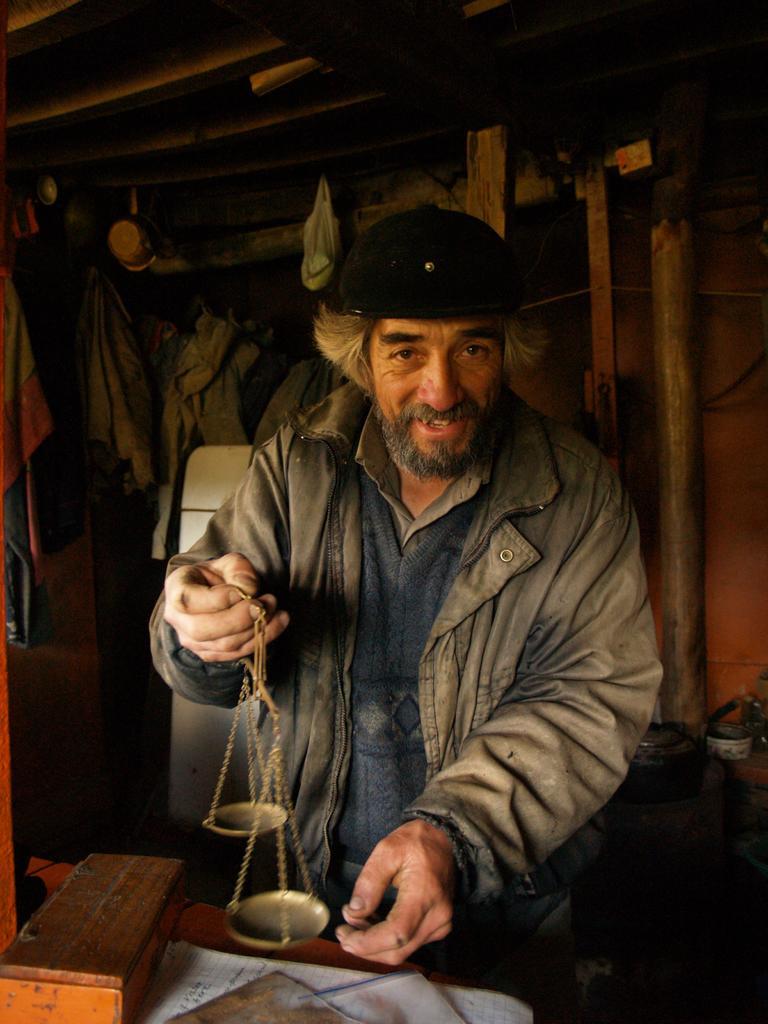In one or two sentences, can you explain what this image depicts? In this picture there is a person standing and holding the object and there are papers and there is a wooden object on the table. At the back there are clothes hanging on the wooden roof. On the right side of the image there are objects. 